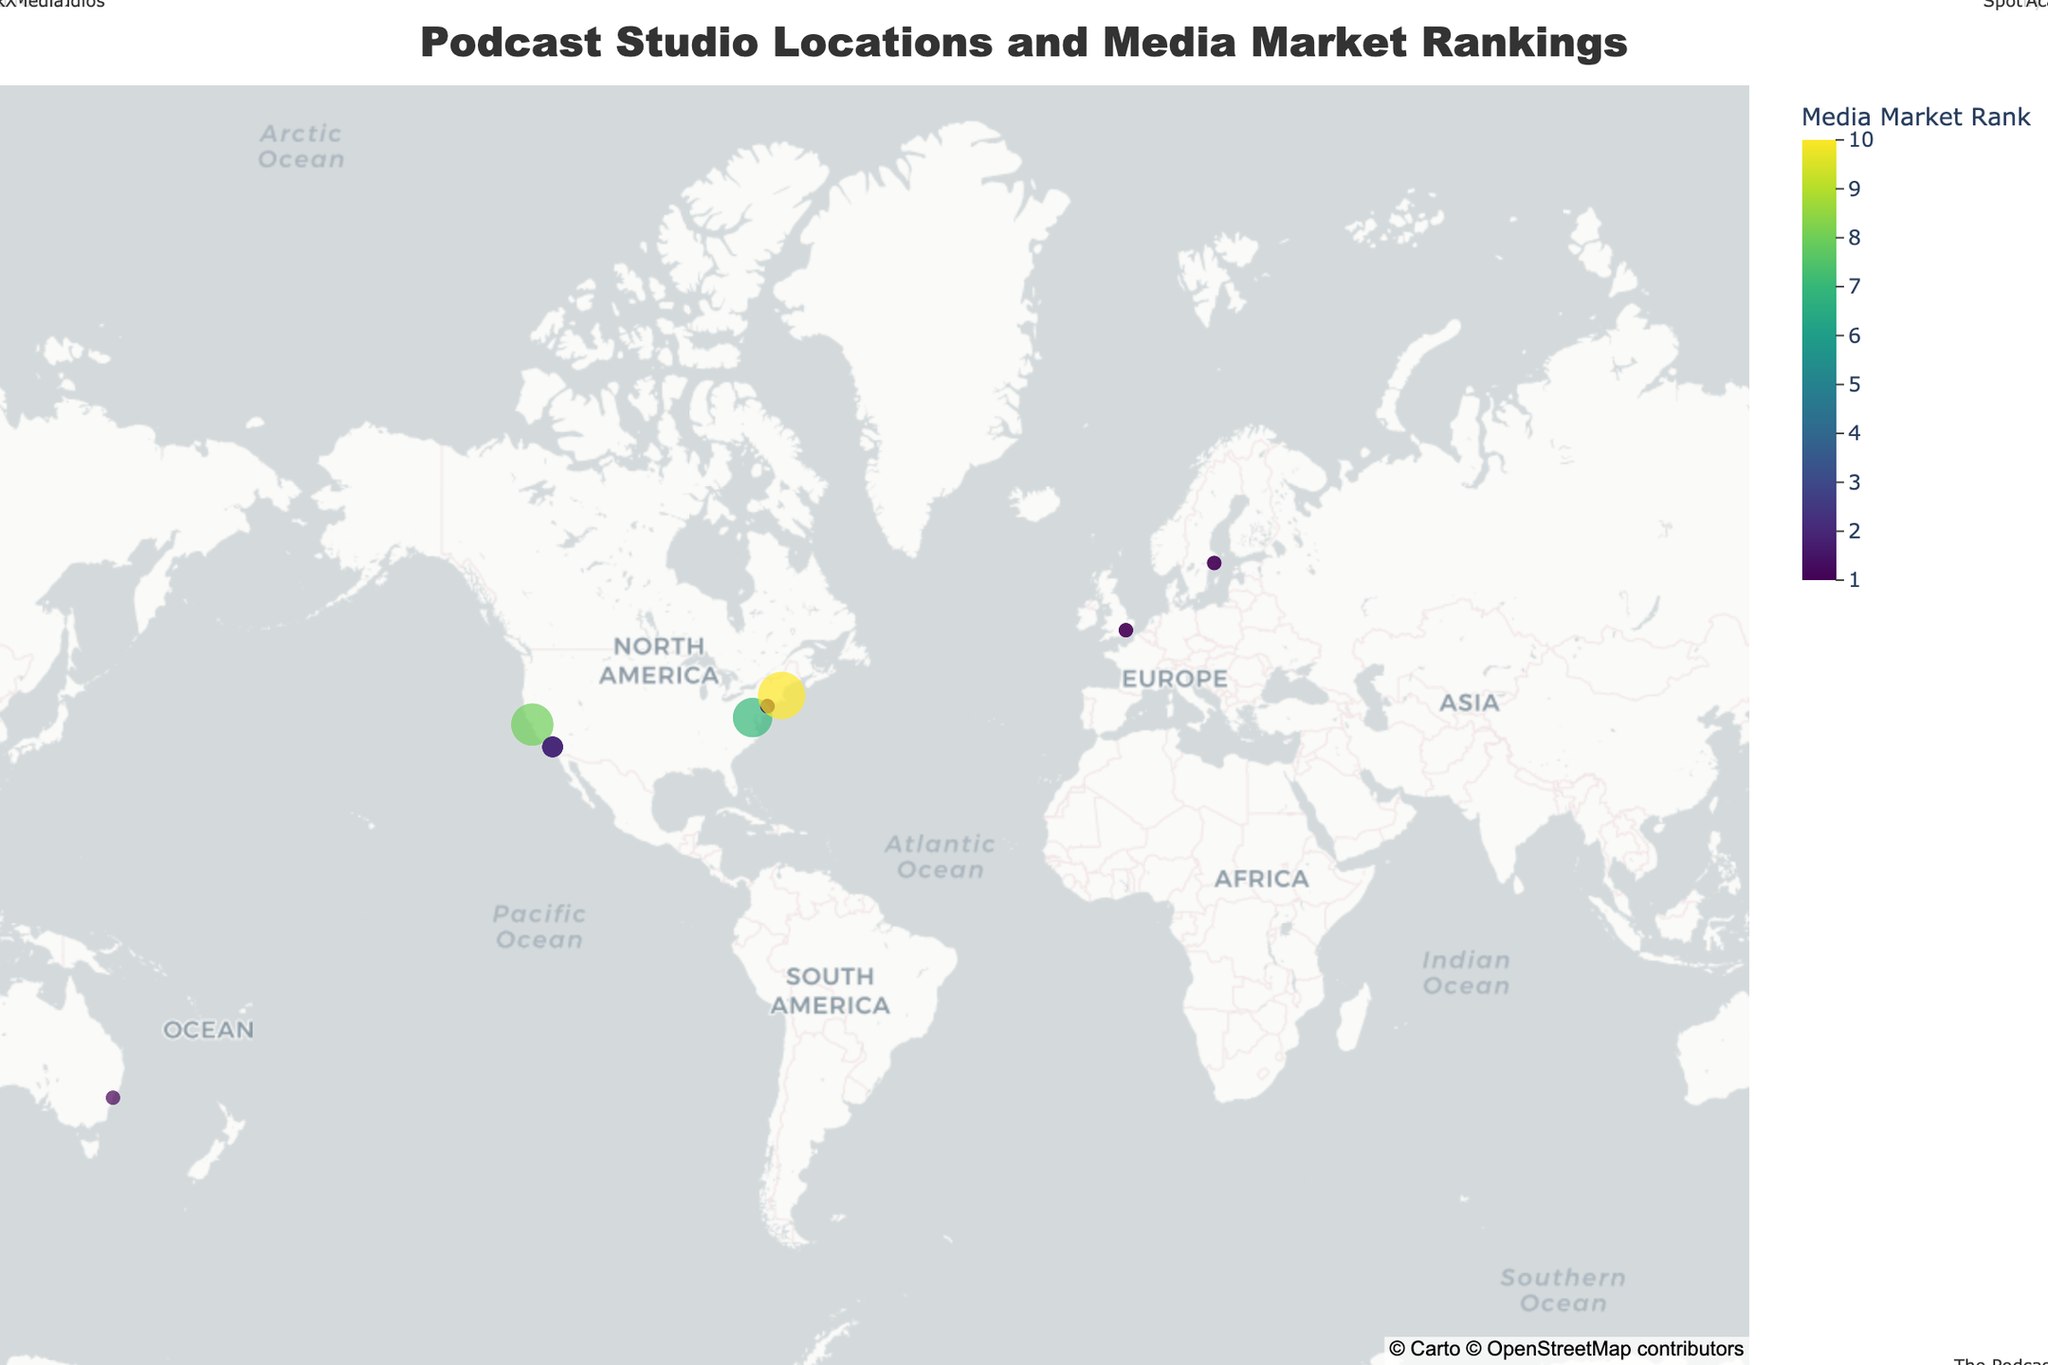What's the title of the figure? The title is located at the top of the figure, it reads "Podcast Studio Locations and Media Market Rankings".
Answer: "Podcast Studio Locations and Media Market Rankings" How many studios are shown in New York City? Check for all data points located in New York City based on the latitude and longitude coordinates, and there are three annotations: Gimlet Media, Stitcher, and Pineapple Street Studios.
Answer: 3 Which city has the second highest media market rank? Los Angeles, with multiple studios, is shown with a media market rank of 2, which is only lower than cities with a rank of 1.
Answer: Los Angeles What is the media market rank of NPR's studio? Locate NPR's annotation in Washington D.C., and check the media market rank shown in the hover data.
Answer: 7 How many studios are located in cities with a media market rank of 1? Identify all data points with a media market rank of 1, and count the studios in New York City, London, Sydney, and Stockholm.
Answer: 8 Which city has the largest number of studios? Count the data points for each city. Los Angeles has the most, with several studios like Wondery, Earwolf, Maximum Fun, and Crooked Media.
Answer: Los Angeles What is the average media market rank of studios in the USA? Identify all studios in the USA and sum their media market ranks: (1+2+8+1+7+10+2+2) = 33, and there are 8 studios, so the average is 33/8 = 4.125.
Answer: 4.125 Which city with a media market rank of 2 has more podcast studios, and how many? Compare the number of studios in cities with a media market rank of 2 (Los Angeles and none other in the list), so Los Angeles has 4 studios.
Answer: Los Angeles, 4 What countries are represented by studios with a media market rank of 1? Identify countries from cities with a media market rank of 1: USA (New York City), UK (London), Australia (Sydney), and Sweden (Stockholm).
Answer: USA, UK, Australia, Sweden 